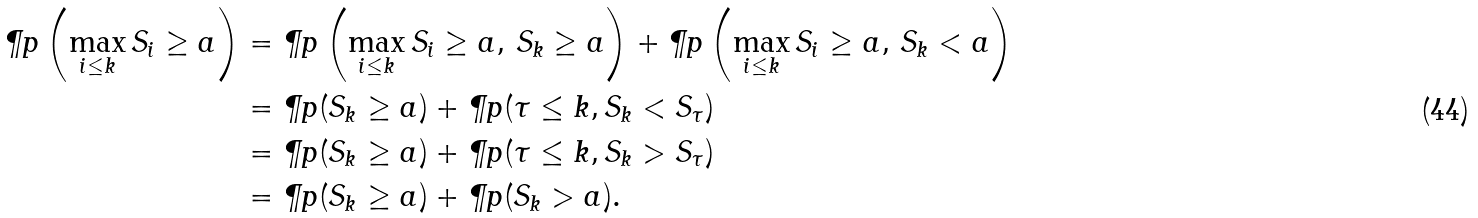<formula> <loc_0><loc_0><loc_500><loc_500>\P p \left ( \max _ { i \leq k } S _ { i } \geq a \right ) & = \P p \left ( \max _ { i \leq k } S _ { i } \geq a , \, S _ { k } \geq a \right ) + \P p \left ( \max _ { i \leq k } S _ { i } \geq a , \, S _ { k } < a \right ) \\ & = \P p ( S _ { k } \geq a ) + \P p ( \tau \leq k , S _ { k } < S _ { \tau } ) \\ & = \P p ( S _ { k } \geq a ) + \P p ( \tau \leq k , S _ { k } > S _ { \tau } ) \\ & = \P p ( S _ { k } \geq a ) + \P p ( S _ { k } > a ) .</formula> 